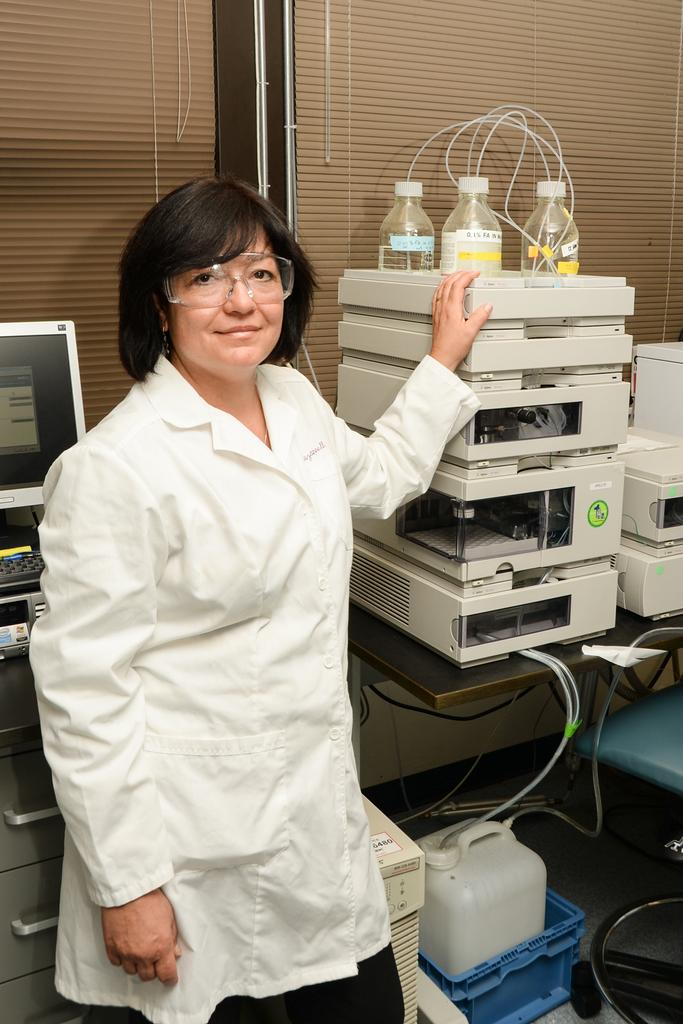Who is the main subject in the image? There is a lady in the image. Where is the lady located in the image? The lady is on the left side of the image. What is the lady doing in the image? The lady is resting her hands on a hand on a machine. What can be inferred about the setting of the image? The setting appears to be a laboratory, likely part of a hospital. What degree does the lady hold in the image? There is no information about the lady's degree in the image. Can you hear a bell ringing in the image? There is no bell present in the image. 